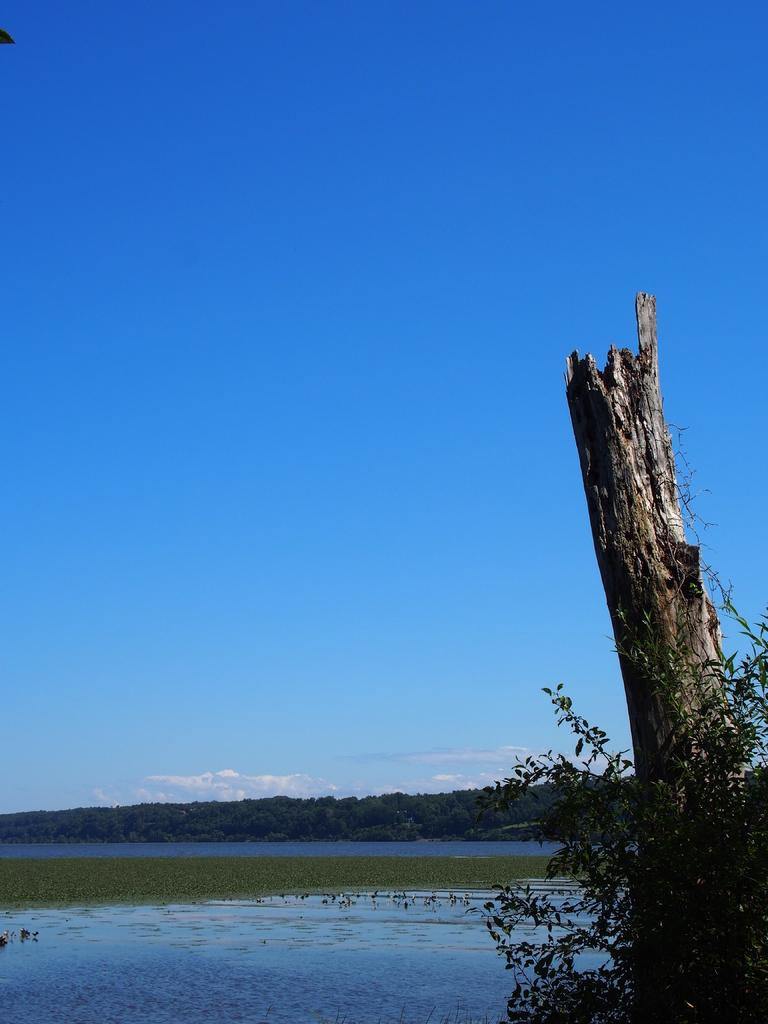What is the primary element present in the image? There is water in the image. What else can be seen in the image besides water? There are trees in the image. What can be seen in the background of the image? There are clouds visible in the background of the image. What type of toothpaste is being used to create the clouds in the image? There is no toothpaste present in the image, and the clouds are a natural part of the sky. 